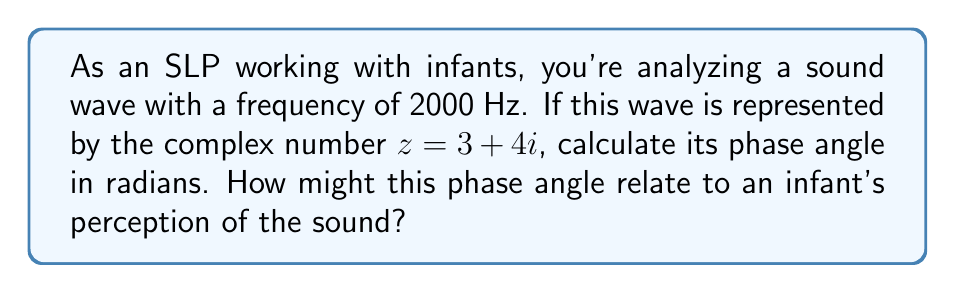Provide a solution to this math problem. To calculate the phase angle of a complex number representing a sound wave frequency, we follow these steps:

1) The complex number is given as $z = 3 + 4i$

2) The phase angle $\theta$ of a complex number $a + bi$ is given by the formula:

   $$\theta = \arctan(\frac{b}{a})$$

3) In our case, $a = 3$ and $b = 4$. Substituting these values:

   $$\theta = \arctan(\frac{4}{3})$$

4) Using a calculator or mathematical tables:

   $$\theta \approx 0.9273 \text{ radians}$$

5) To convert to degrees (if needed):

   $$\theta \approx 0.9273 \times \frac{180}{\pi} \approx 53.13°$$

This phase angle represents the initial angle of the sound wave relative to a reference point. In the context of infant auditory perception, this could relate to the timing of when the sound reaches peak amplitude, potentially affecting how the infant processes and responds to the sound. Different phase angles might influence the infant's ability to localize or distinguish between sounds, which is crucial for early language development.
Answer: $0.9273 \text{ radians}$ 